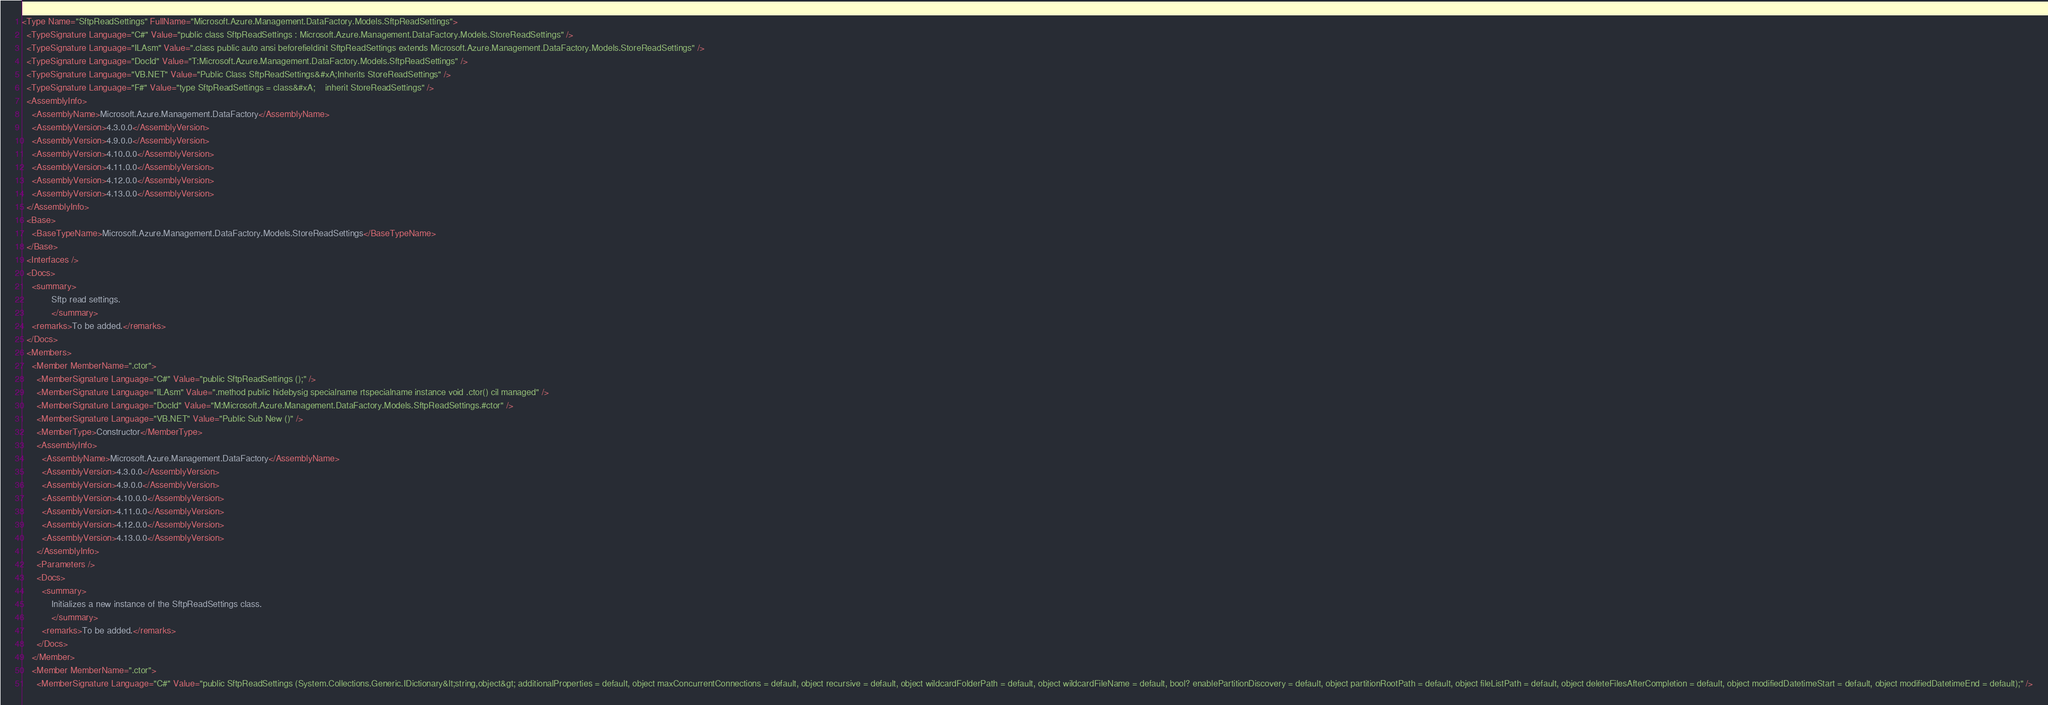Convert code to text. <code><loc_0><loc_0><loc_500><loc_500><_XML_><Type Name="SftpReadSettings" FullName="Microsoft.Azure.Management.DataFactory.Models.SftpReadSettings">
  <TypeSignature Language="C#" Value="public class SftpReadSettings : Microsoft.Azure.Management.DataFactory.Models.StoreReadSettings" />
  <TypeSignature Language="ILAsm" Value=".class public auto ansi beforefieldinit SftpReadSettings extends Microsoft.Azure.Management.DataFactory.Models.StoreReadSettings" />
  <TypeSignature Language="DocId" Value="T:Microsoft.Azure.Management.DataFactory.Models.SftpReadSettings" />
  <TypeSignature Language="VB.NET" Value="Public Class SftpReadSettings&#xA;Inherits StoreReadSettings" />
  <TypeSignature Language="F#" Value="type SftpReadSettings = class&#xA;    inherit StoreReadSettings" />
  <AssemblyInfo>
    <AssemblyName>Microsoft.Azure.Management.DataFactory</AssemblyName>
    <AssemblyVersion>4.3.0.0</AssemblyVersion>
    <AssemblyVersion>4.9.0.0</AssemblyVersion>
    <AssemblyVersion>4.10.0.0</AssemblyVersion>
    <AssemblyVersion>4.11.0.0</AssemblyVersion>
    <AssemblyVersion>4.12.0.0</AssemblyVersion>
    <AssemblyVersion>4.13.0.0</AssemblyVersion>
  </AssemblyInfo>
  <Base>
    <BaseTypeName>Microsoft.Azure.Management.DataFactory.Models.StoreReadSettings</BaseTypeName>
  </Base>
  <Interfaces />
  <Docs>
    <summary>
            Sftp read settings.
            </summary>
    <remarks>To be added.</remarks>
  </Docs>
  <Members>
    <Member MemberName=".ctor">
      <MemberSignature Language="C#" Value="public SftpReadSettings ();" />
      <MemberSignature Language="ILAsm" Value=".method public hidebysig specialname rtspecialname instance void .ctor() cil managed" />
      <MemberSignature Language="DocId" Value="M:Microsoft.Azure.Management.DataFactory.Models.SftpReadSettings.#ctor" />
      <MemberSignature Language="VB.NET" Value="Public Sub New ()" />
      <MemberType>Constructor</MemberType>
      <AssemblyInfo>
        <AssemblyName>Microsoft.Azure.Management.DataFactory</AssemblyName>
        <AssemblyVersion>4.3.0.0</AssemblyVersion>
        <AssemblyVersion>4.9.0.0</AssemblyVersion>
        <AssemblyVersion>4.10.0.0</AssemblyVersion>
        <AssemblyVersion>4.11.0.0</AssemblyVersion>
        <AssemblyVersion>4.12.0.0</AssemblyVersion>
        <AssemblyVersion>4.13.0.0</AssemblyVersion>
      </AssemblyInfo>
      <Parameters />
      <Docs>
        <summary>
            Initializes a new instance of the SftpReadSettings class.
            </summary>
        <remarks>To be added.</remarks>
      </Docs>
    </Member>
    <Member MemberName=".ctor">
      <MemberSignature Language="C#" Value="public SftpReadSettings (System.Collections.Generic.IDictionary&lt;string,object&gt; additionalProperties = default, object maxConcurrentConnections = default, object recursive = default, object wildcardFolderPath = default, object wildcardFileName = default, bool? enablePartitionDiscovery = default, object partitionRootPath = default, object fileListPath = default, object deleteFilesAfterCompletion = default, object modifiedDatetimeStart = default, object modifiedDatetimeEnd = default);" /></code> 